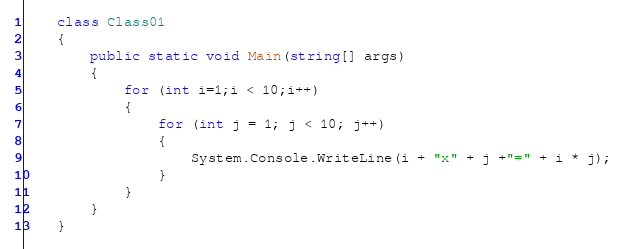<code> <loc_0><loc_0><loc_500><loc_500><_C#_>    class Class01
    {
        public static void Main(string[] args)
        {
            for (int i=1;i < 10;i++)
            {
                for (int j = 1; j < 10; j++)
                {
                    System.Console.WriteLine(i + "x" + j +"=" + i * j);
                }
            }
        }
    }</code> 